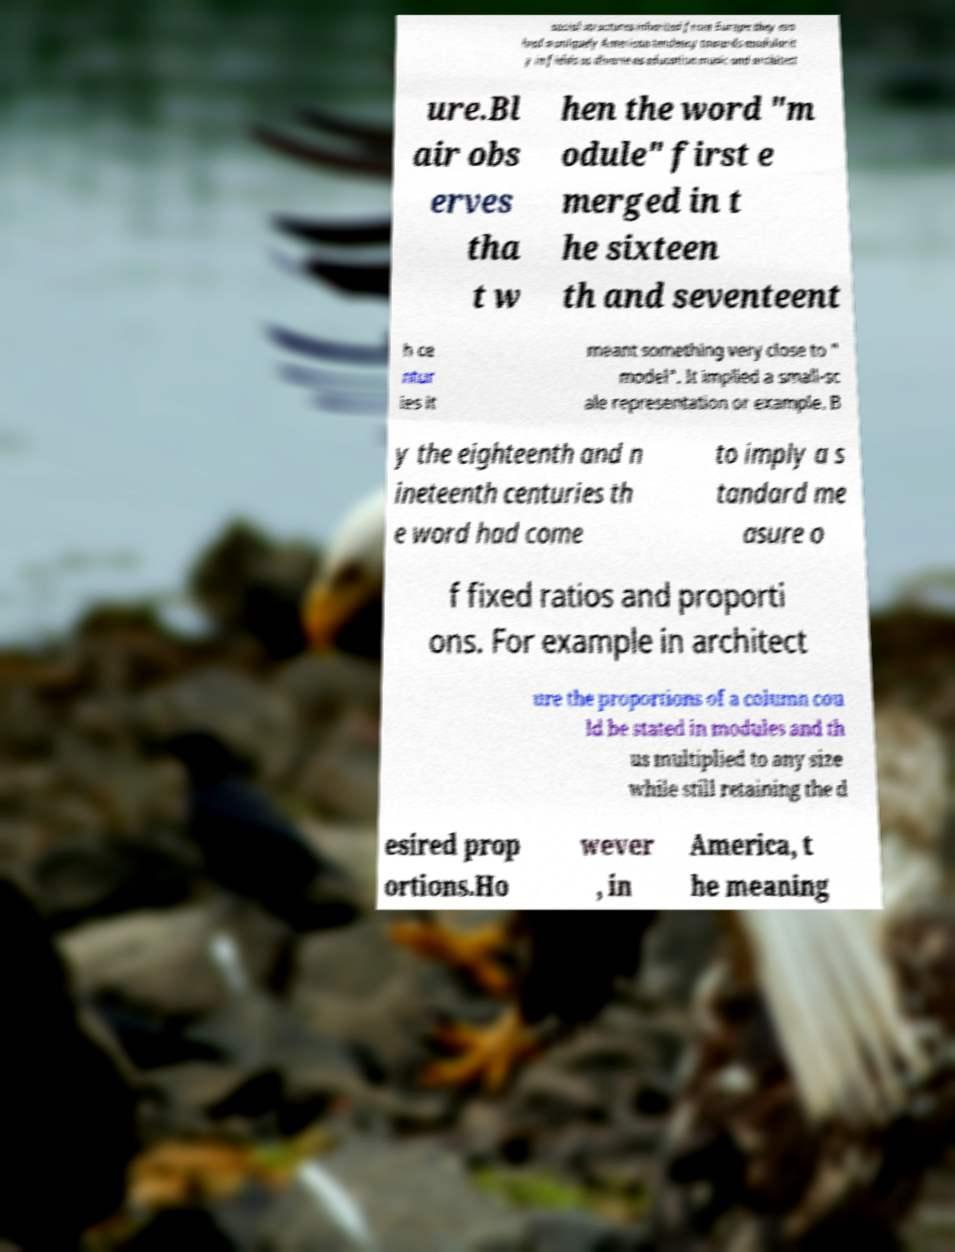There's text embedded in this image that I need extracted. Can you transcribe it verbatim? social structures inherited from Europe they evo lved a uniquely American tendency towards modularit y in fields as diverse as education music and architect ure.Bl air obs erves tha t w hen the word "m odule" first e merged in t he sixteen th and seventeent h ce ntur ies it meant something very close to " model". It implied a small-sc ale representation or example. B y the eighteenth and n ineteenth centuries th e word had come to imply a s tandard me asure o f fixed ratios and proporti ons. For example in architect ure the proportions of a column cou ld be stated in modules and th us multiplied to any size while still retaining the d esired prop ortions.Ho wever , in America, t he meaning 